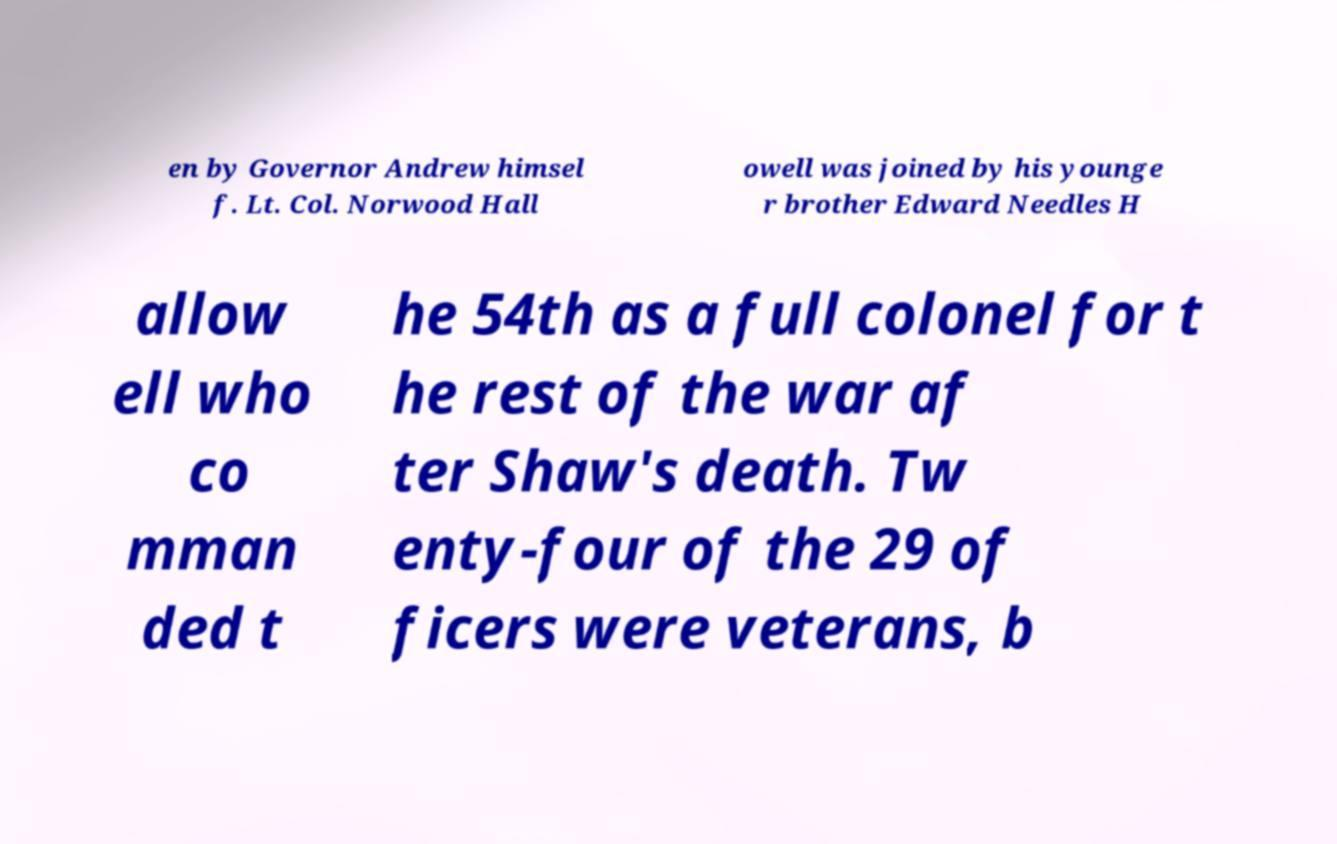I need the written content from this picture converted into text. Can you do that? en by Governor Andrew himsel f. Lt. Col. Norwood Hall owell was joined by his younge r brother Edward Needles H allow ell who co mman ded t he 54th as a full colonel for t he rest of the war af ter Shaw's death. Tw enty-four of the 29 of ficers were veterans, b 